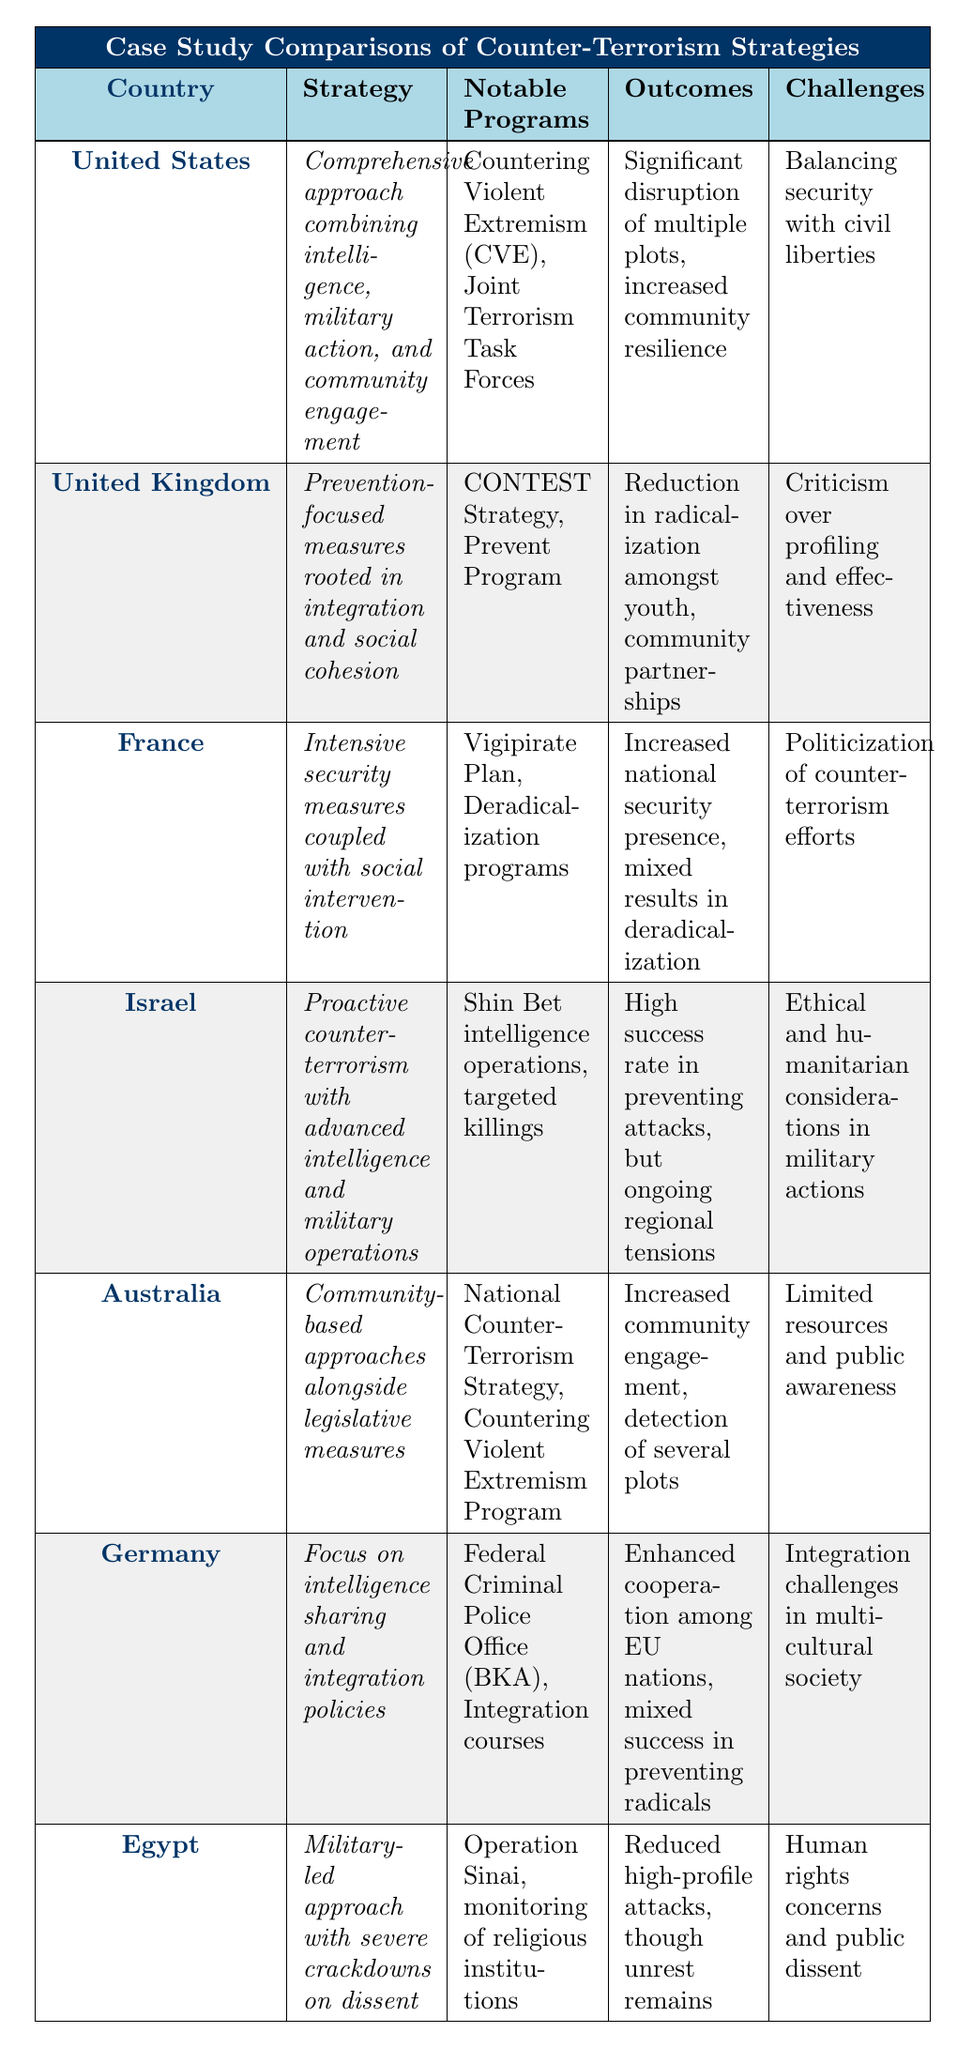What is the counter-terrorism strategy employed by Israel? The table shows that Israel's strategy is described as "Proactive counter-terrorism with advanced intelligence and military operations."
Answer: Proactive counter-terrorism with advanced intelligence and military operations Which country has a strategy focused on community engagement? According to the table, the United States implements a strategy that combines intelligence, military action, and community engagement.
Answer: United States What notable program is associated with Germany's counter-terrorism strategy? The table indicates that Germany has notable programs such as the Federal Criminal Police Office (BKA) and integration courses.
Answer: Federal Criminal Police Office (BKA) Is the United Kingdom's strategy characterized by military action? The table states that the United Kingdom's strategy is "Prevention-focused measures rooted in integration and social cohesion," which does not mention military action.
Answer: No Which country reports increased community engagement as an outcome of their counter-terrorism strategy? From the table, Australia lists increased community engagement as one of the outcomes of their National Counter-Terrorism Strategy and Countering Violent Extremism Program.
Answer: Australia How many countries employ a strategy that combines intelligence and military action? The table shows that both the United States and Israel combine intelligence and military action in their strategies; thus, there are two countries.
Answer: 2 What are the challenges faced by Egypt in its counter-terrorism approach? The table lists human rights concerns and public dissent as the challenges faced by Egypt in their military-led approach to counter-terrorism.
Answer: Human rights concerns and public dissent Which country's strategy has mixed results in deradicalization? The table notes that France has mixed results in deradicalization as an outcome of its intensive security measures coupled with social intervention.
Answer: France What is the main focus of Australia's counter-terrorism strategy? According to the table, Australia's main focus is on community-based approaches alongside legislative measures.
Answer: Community-based approaches alongside legislative measures Which country has faced criticism over profiling in their counter-terrorism efforts? The United Kingdom is mentioned in the table as facing criticism over profiling and effectiveness in its prevention-focused measures.
Answer: United Kingdom 